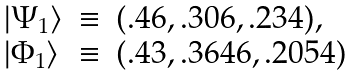Convert formula to latex. <formula><loc_0><loc_0><loc_500><loc_500>\begin{array} { l c l } | \Psi _ { 1 } \rangle & \equiv & ( . 4 6 , . 3 0 6 , . 2 3 4 ) , \\ | \Phi _ { 1 } \rangle & \equiv & ( . 4 3 , . 3 6 4 6 , . 2 0 5 4 ) \end{array}</formula> 